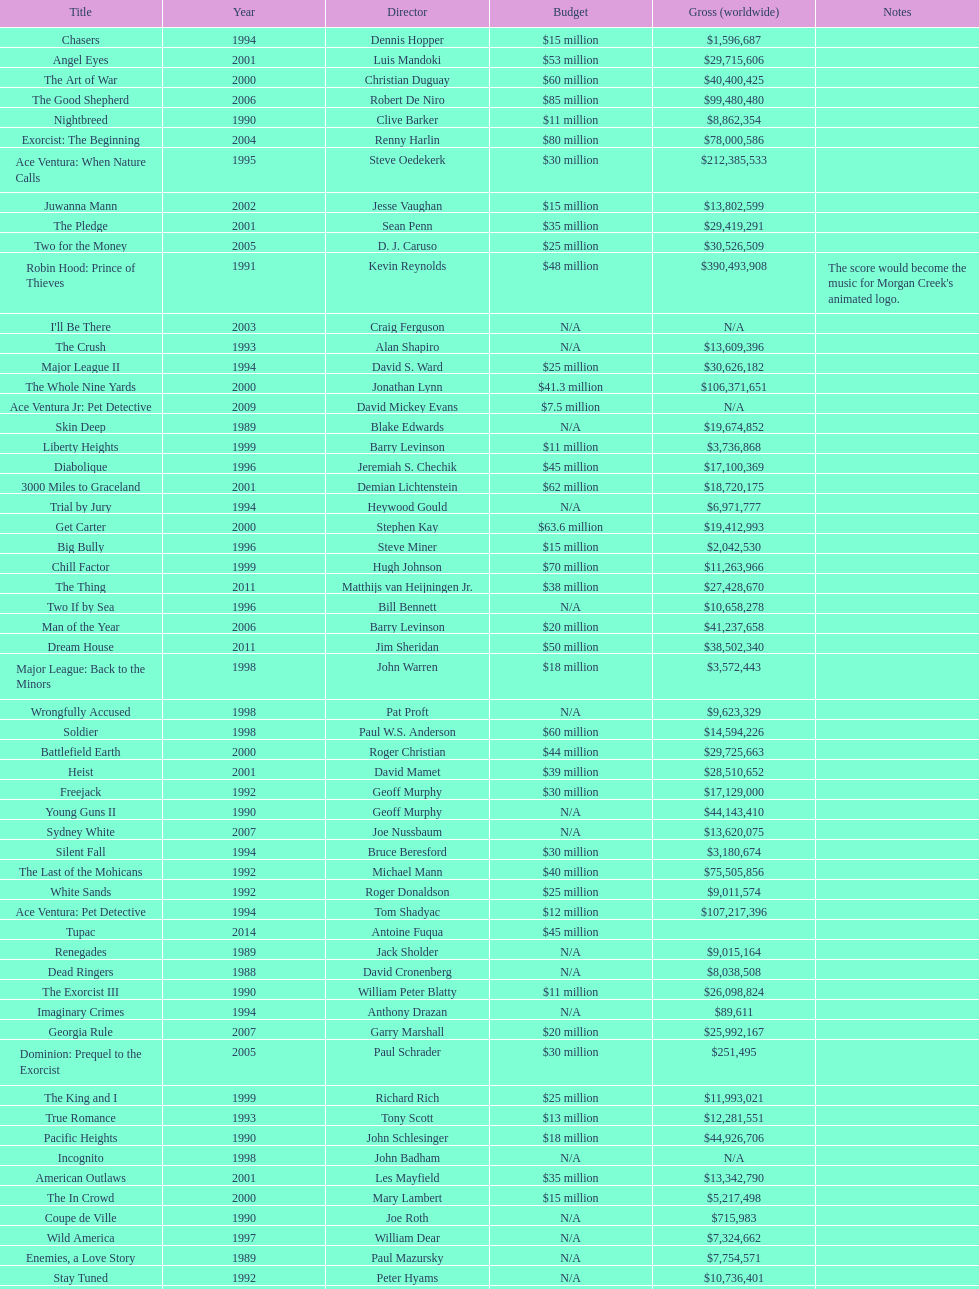Which film had a higher budget, ace ventura: when nature calls, or major league: back to the minors? Ace Ventura: When Nature Calls. 